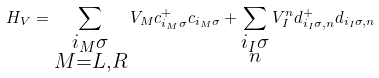Convert formula to latex. <formula><loc_0><loc_0><loc_500><loc_500>H _ { V } = \sum _ { \substack { i _ { M } \sigma \\ M = L , R } } V _ { M } c _ { i _ { M } \sigma } ^ { + } c _ { i _ { M } \sigma } + \sum _ { \substack { i _ { I } \sigma \\ n } } V _ { I } ^ { n } d _ { i _ { I } \sigma , n } ^ { + } d _ { i _ { I } \sigma , n }</formula> 